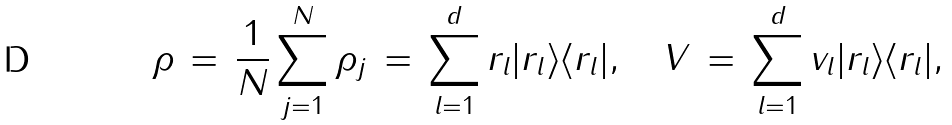<formula> <loc_0><loc_0><loc_500><loc_500>\rho \, = \, \frac { 1 } { N } \sum _ { j = 1 } ^ { N } \rho _ { j } \, = \, \sum _ { l = 1 } ^ { d } r _ { l } | r _ { l } \rangle \langle r _ { l } | , \quad V \, = \, \sum _ { l = 1 } ^ { d } v _ { l } | r _ { l } \rangle \langle r _ { l } | ,</formula> 